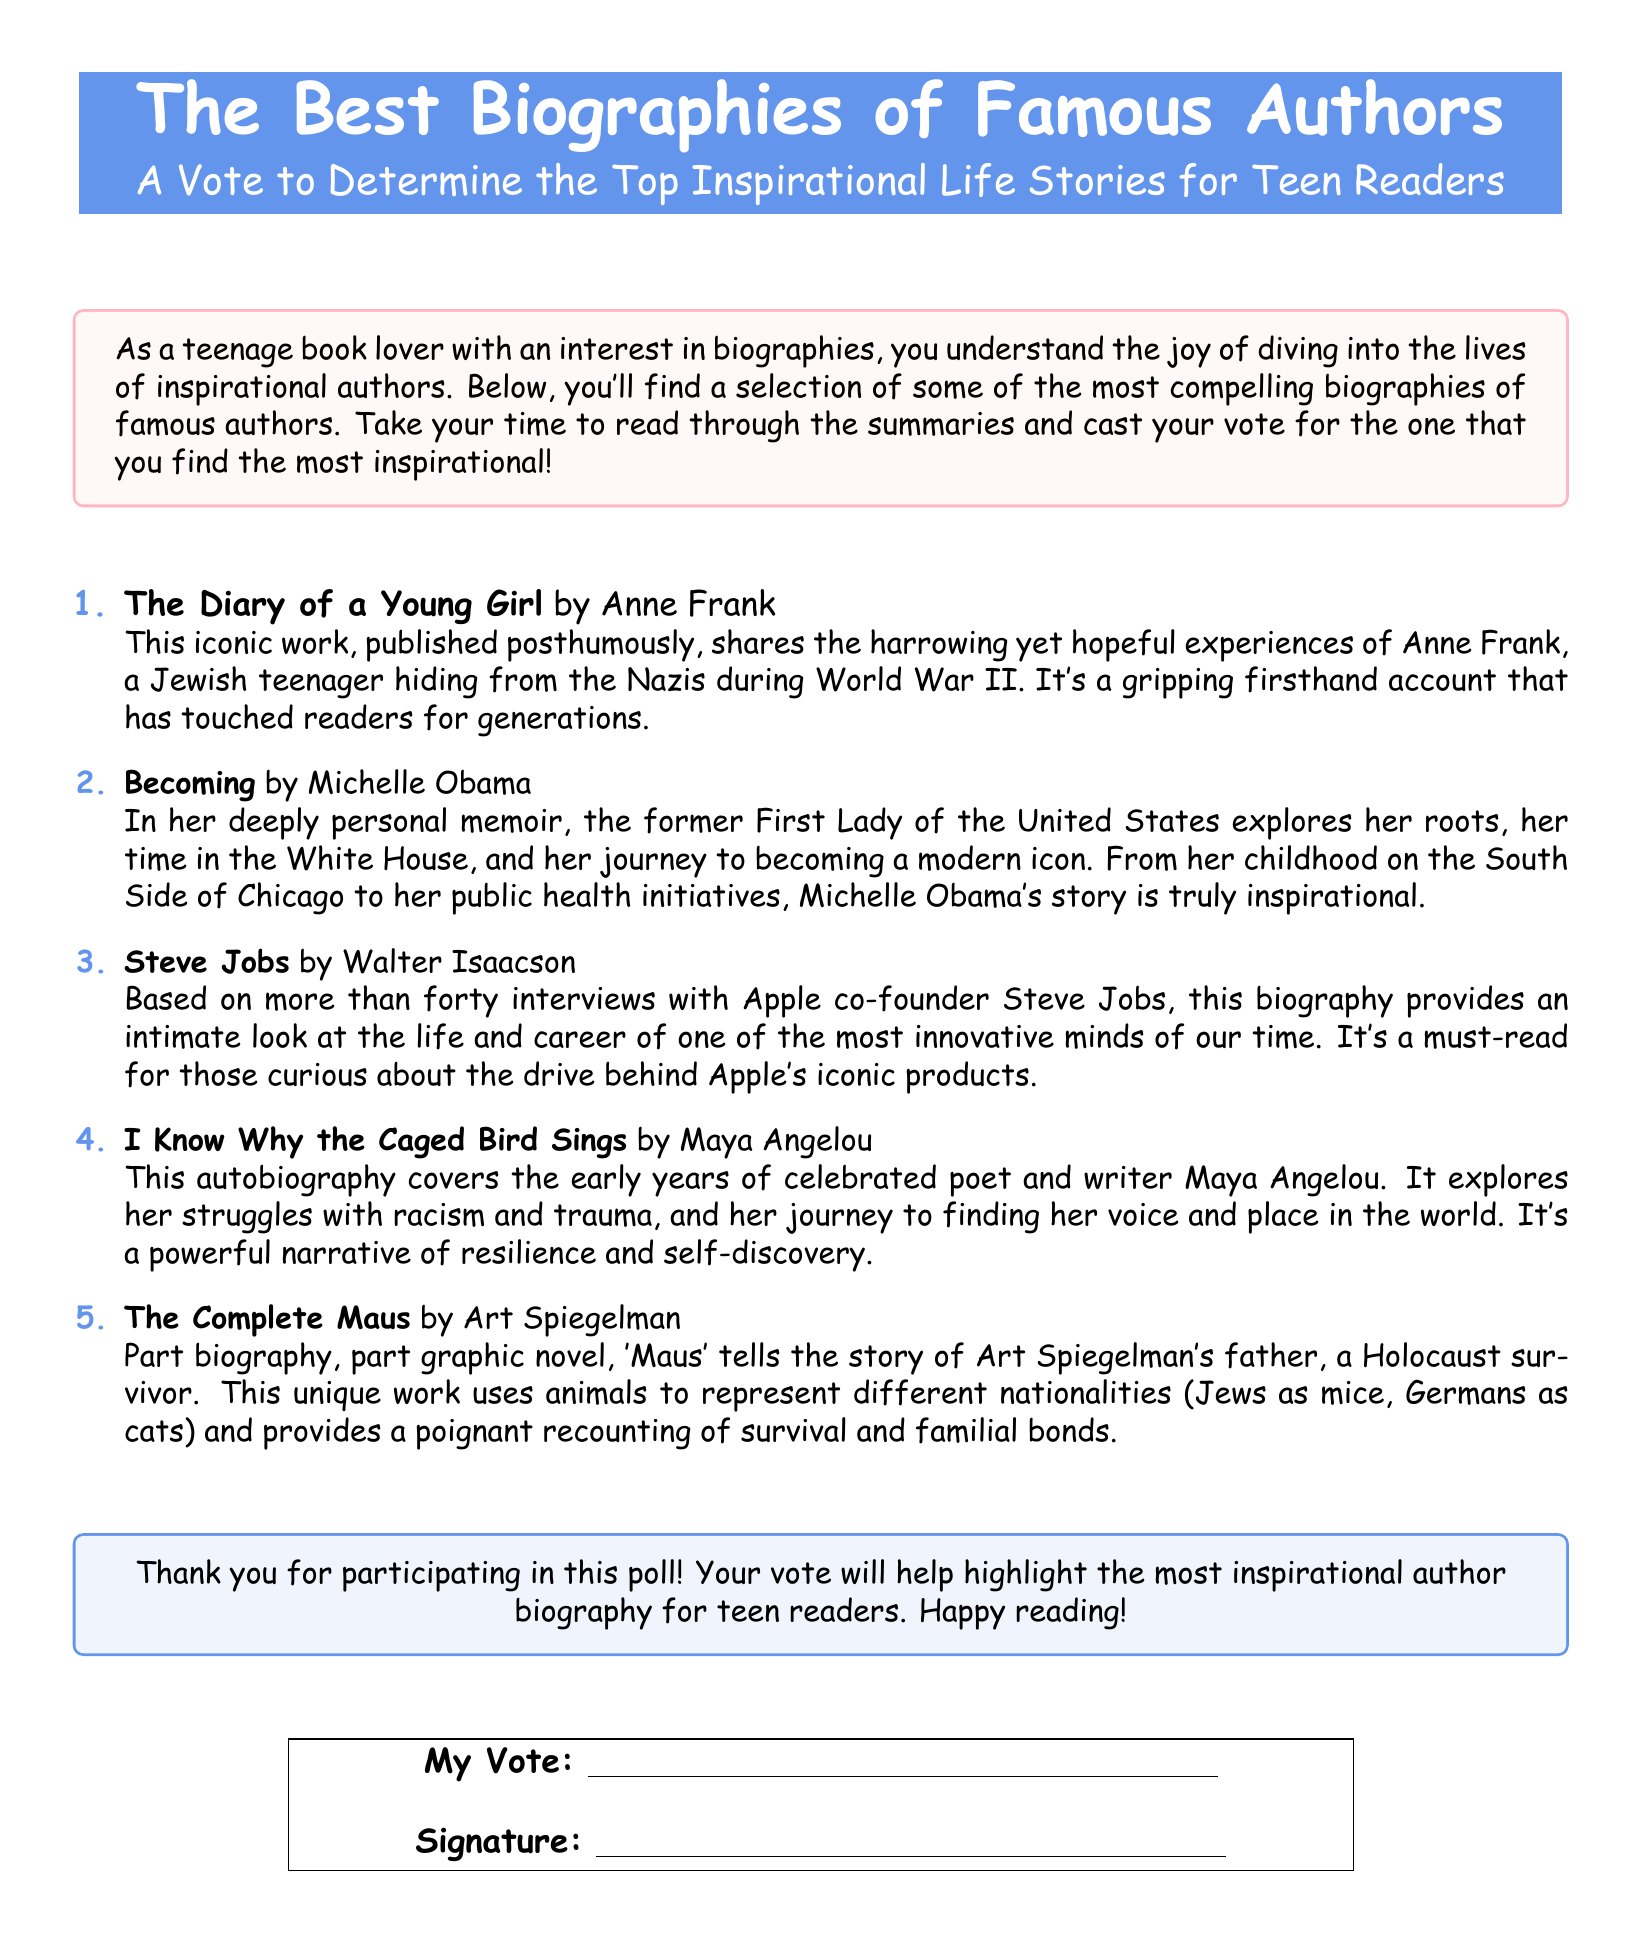What is the title of the ballot? The title of the ballot is presented in the header of the document, which identifies the main topic.
Answer: The Best Biographies of Famous Authors Who is the author of "The Diary of a Young Girl"? The document lists the author of this biography, showcasing her importance in the context of the ballot.
Answer: Anne Frank How many biographies are listed in the poll? The number of items in the enumeration section of the document indicates how many biographies are featured.
Answer: Five Which biography focuses on a former First Lady? The document specifies one of the biographies, highlighting who it is centered around in the summary.
Answer: Becoming What is the main theme of "I Know Why the Caged Bird Sings"? The theme is mentioned in the description of the autobiography, indicating its focus on personal challenges and identity.
Answer: Resilience and self-discovery What unique format does "The Complete Maus" utilize? The description of this biography reveals that it combines elements of traditional biography with another creative format.
Answer: Graphic novel Which author is known for discussing their childhood on the South Side of Chicago? The summary of one biography specifically references the author's background that relates to the geographical setting.
Answer: Michelle Obama What does the ballot ask participants to do? The document makes it clear that it requests a specific action from the readers at the end.
Answer: Cast your vote 